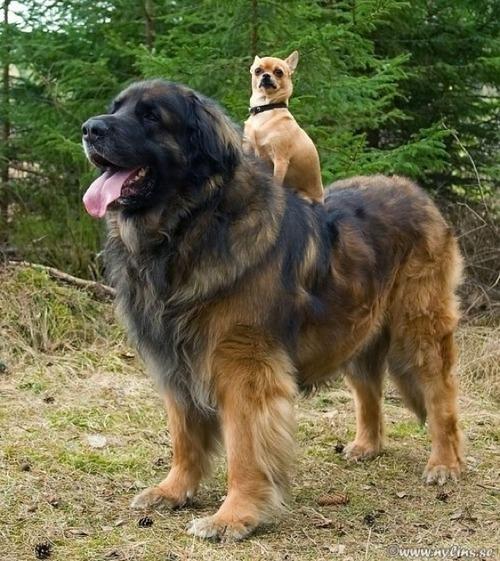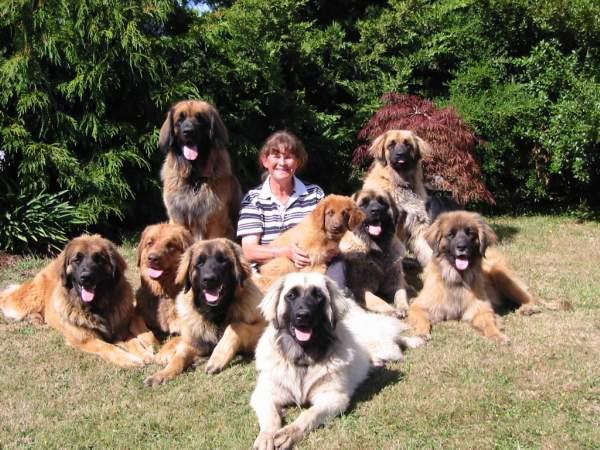The first image is the image on the left, the second image is the image on the right. Analyze the images presented: Is the assertion "The right image contains at least four dogs." valid? Answer yes or no. Yes. 